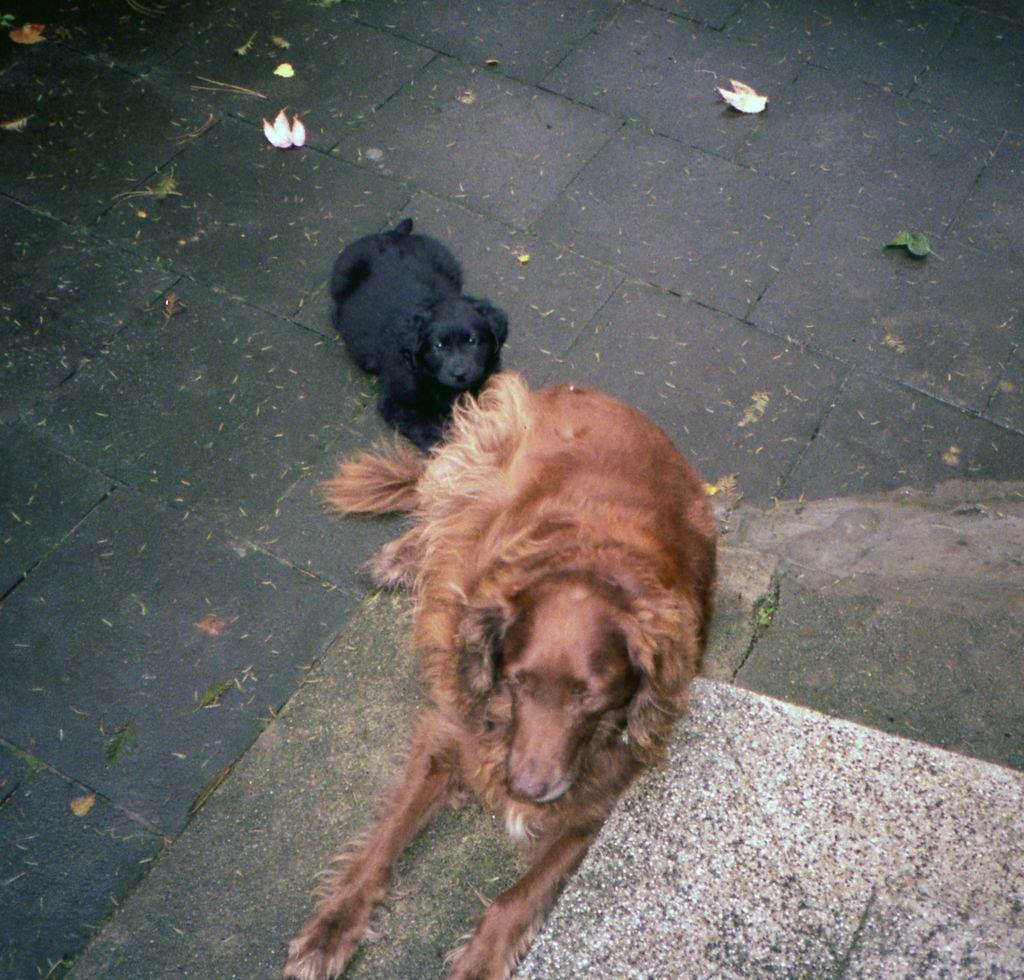Can you describe this image briefly? In this image in the center there are two dogs and in the background there is a road. 